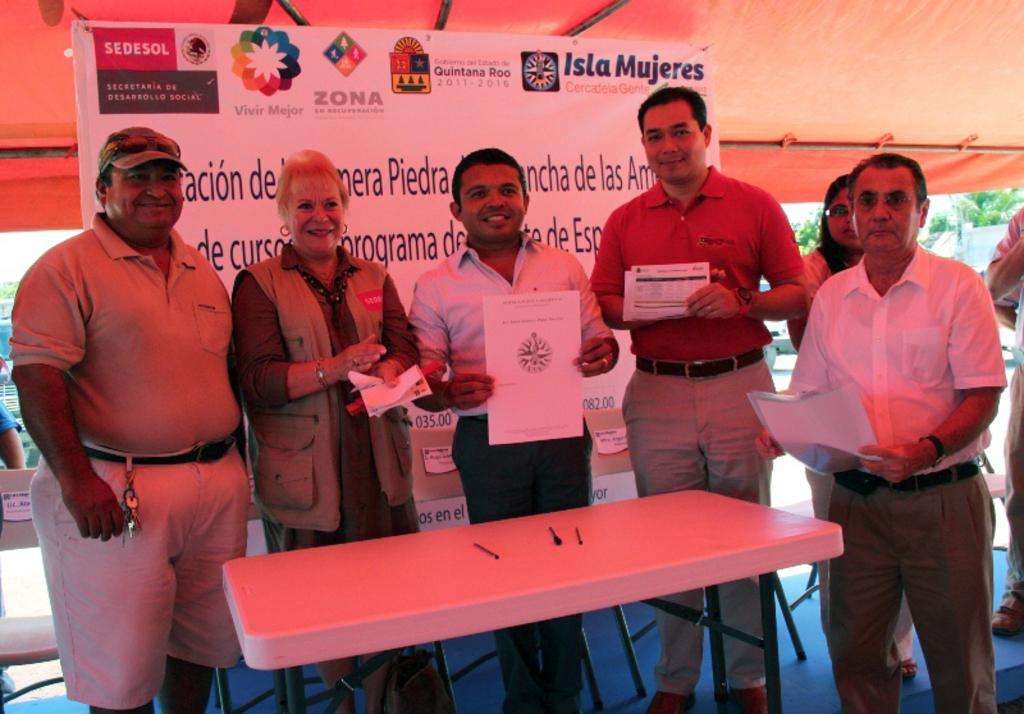How many people are in the image? There is a group of persons in the image. Where are the persons located in the image? The persons are standing on a stage. What are the persons holding in their hands? The persons are holding papers in their hands. What can be seen in the background of the image? There is a board visible in the background of the image. What type of hole can be seen in the image? There is no hole present in the image. What kind of quilt is being used by the persons on the stage? There is no quilt present in the image; the persons are holding papers in their hands. 